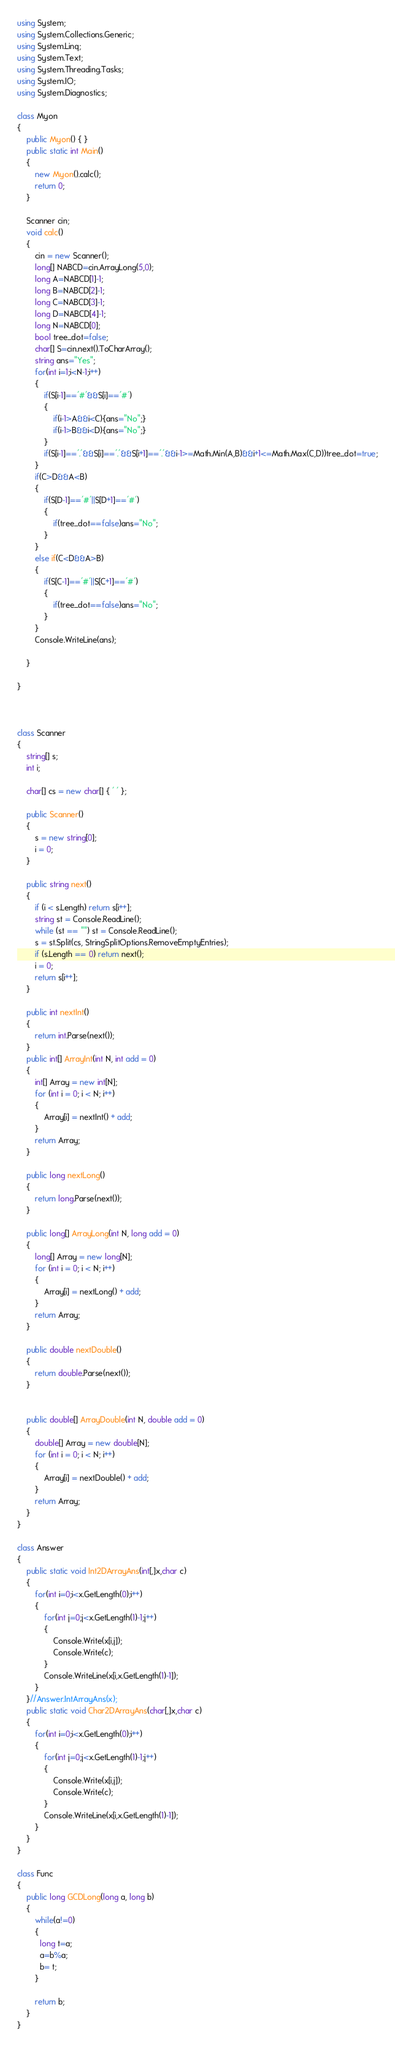<code> <loc_0><loc_0><loc_500><loc_500><_C#_>using System;
using System.Collections.Generic;
using System.Linq;
using System.Text;
using System.Threading.Tasks;
using System.IO;
using System.Diagnostics;

class Myon
{
    public Myon() { }
    public static int Main()
    {
        new Myon().calc();
        return 0;
    }

    Scanner cin;
    void calc()
    {
        cin = new Scanner();
        long[] NABCD=cin.ArrayLong(5,0);
        long A=NABCD[1]-1;
        long B=NABCD[2]-1;
        long C=NABCD[3]-1;
        long D=NABCD[4]-1;
        long N=NABCD[0];
        bool tree_dot=false;
        char[] S=cin.next().ToCharArray();
        string ans="Yes";
        for(int i=1;i<N-1;i++)
        {
            if(S[i-1]=='#'&&S[i]=='#')
            {
                if(i-1>A&&i<C){ans="No";}
                if(i-1>B&&i<D){ans="No";}
            }
            if(S[i-1]=='.'&&S[i]=='.'&&S[i+1]=='.'&&i-1>=Math.Min(A,B)&&i+1<=Math.Max(C,D))tree_dot=true;
        }
        if(C>D&&A<B)
        {
            if(S[D-1]=='#'||S[D+1]=='#')
            {
                if(tree_dot==false)ans="No";
            }
        }
        else if(C<D&&A>B)
        {
            if(S[C-1]=='#'||S[C+1]=='#')
            {
                if(tree_dot==false)ans="No";
            }
        }
        Console.WriteLine(ans);
        
    }

}



class Scanner
{
    string[] s;
    int i;

    char[] cs = new char[] { ' ' };

    public Scanner()
    {
        s = new string[0];
        i = 0;
    }

    public string next()
    {
        if (i < s.Length) return s[i++];
        string st = Console.ReadLine();
        while (st == "") st = Console.ReadLine();
        s = st.Split(cs, StringSplitOptions.RemoveEmptyEntries);
        if (s.Length == 0) return next();
        i = 0;
        return s[i++];
    }

    public int nextInt()
    {
        return int.Parse(next());
    }
    public int[] ArrayInt(int N, int add = 0)
    {
        int[] Array = new int[N];
        for (int i = 0; i < N; i++)
        {
            Array[i] = nextInt() + add;
        }
        return Array;
    }

    public long nextLong()
    {
        return long.Parse(next());
    }

    public long[] ArrayLong(int N, long add = 0)
    {
        long[] Array = new long[N];
        for (int i = 0; i < N; i++)
        {
            Array[i] = nextLong() + add;
        }
        return Array;
    }

    public double nextDouble()
    {
        return double.Parse(next());
    }


    public double[] ArrayDouble(int N, double add = 0)
    {
        double[] Array = new double[N];
        for (int i = 0; i < N; i++)
        {
            Array[i] = nextDouble() + add;
        }
        return Array;
    }
}

class Answer
{
    public static void Int2DArrayAns(int[,]x,char c)
    {
        for(int i=0;i<x.GetLength(0);i++)
        {
            for(int j=0;j<x.GetLength(1)-1;j++)
            {
                Console.Write(x[i,j]);
                Console.Write(c);
            }
            Console.WriteLine(x[i,x.GetLength(1)-1]);
        }
    }//Answer.IntArrayAns(x);
    public static void Char2DArrayAns(char[,]x,char c)
    {
        for(int i=0;i<x.GetLength(0);i++)
        {
            for(int j=0;j<x.GetLength(1)-1;j++)
            {
                Console.Write(x[i,j]);
                Console.Write(c);
            }
            Console.WriteLine(x[i,x.GetLength(1)-1]);
        }
    }
}

class Func
{
    public long GCDLong(long a, long b)
    {
        while(a!=0)
        {
          long t=a;
          a=b%a;
          b= t;
        }
      
        return b;        
    }
}</code> 